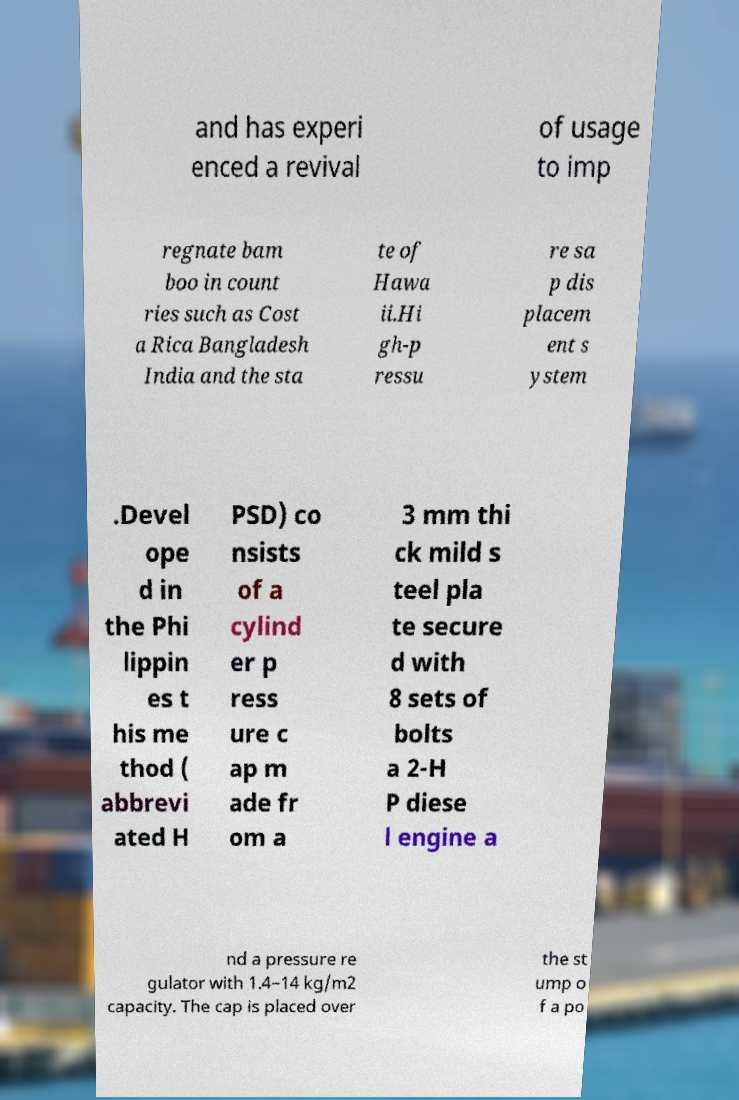I need the written content from this picture converted into text. Can you do that? and has experi enced a revival of usage to imp regnate bam boo in count ries such as Cost a Rica Bangladesh India and the sta te of Hawa ii.Hi gh-p ressu re sa p dis placem ent s ystem .Devel ope d in the Phi lippin es t his me thod ( abbrevi ated H PSD) co nsists of a cylind er p ress ure c ap m ade fr om a 3 mm thi ck mild s teel pla te secure d with 8 sets of bolts a 2-H P diese l engine a nd a pressure re gulator with 1.4–14 kg/m2 capacity. The cap is placed over the st ump o f a po 